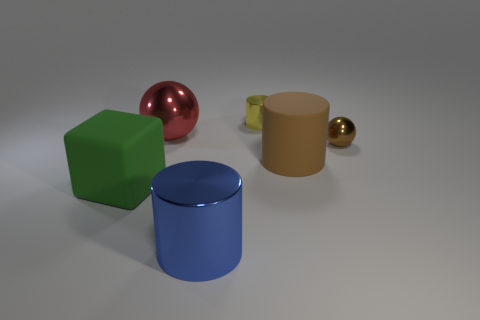What is the blue object made of?
Offer a terse response. Metal. There is a object that is in front of the rubber block; what is its size?
Ensure brevity in your answer.  Large. How many yellow things have the same shape as the blue shiny thing?
Offer a terse response. 1. There is a red thing that is made of the same material as the tiny cylinder; what is its shape?
Provide a succinct answer. Sphere. How many purple things are either tiny balls or large matte objects?
Your answer should be very brief. 0. Are there any big red spheres behind the big red metal thing?
Keep it short and to the point. No. There is a big red metallic object that is on the left side of the big blue cylinder; does it have the same shape as the big matte object that is to the right of the big blue metallic object?
Your answer should be very brief. No. What is the material of the tiny yellow thing that is the same shape as the blue thing?
Offer a terse response. Metal. How many blocks are green things or small red things?
Ensure brevity in your answer.  1. What number of spheres have the same material as the yellow cylinder?
Provide a succinct answer. 2. 